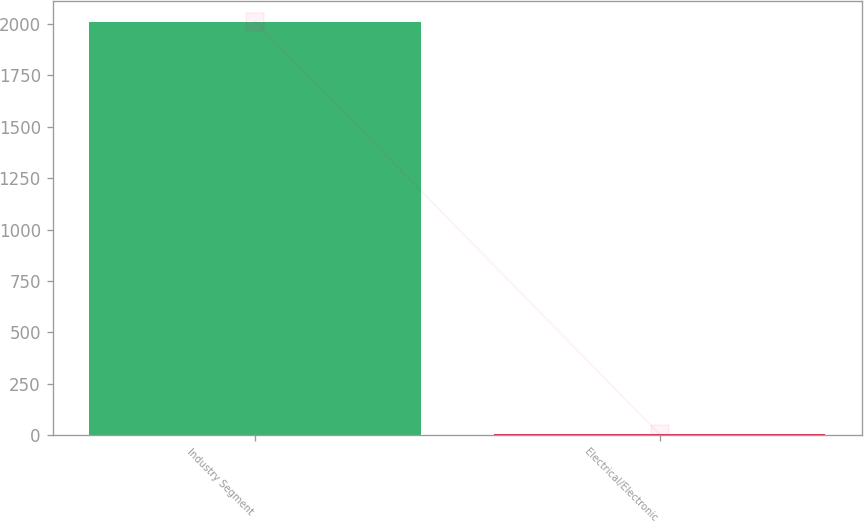<chart> <loc_0><loc_0><loc_500><loc_500><bar_chart><fcel>Industry Segment<fcel>Electrical/Electronic<nl><fcel>2012<fcel>4<nl></chart> 